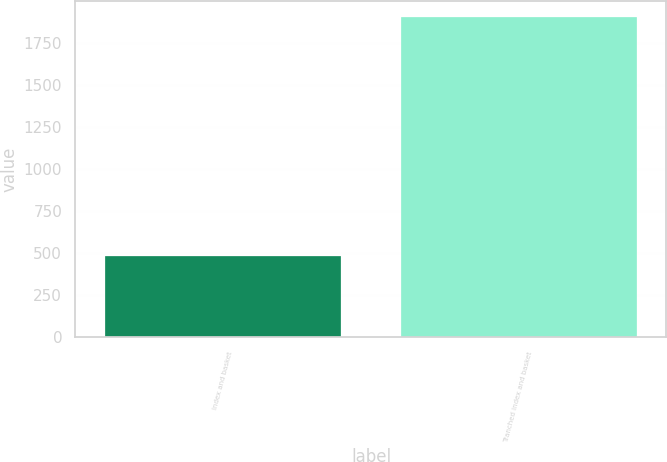Convert chart to OTSL. <chart><loc_0><loc_0><loc_500><loc_500><bar_chart><fcel>Index and basket<fcel>Tranched index and basket<nl><fcel>481<fcel>1900<nl></chart> 